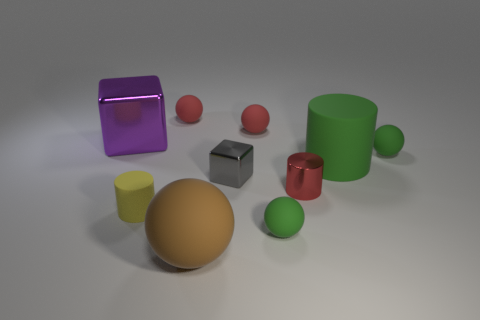What material is the red cylinder?
Make the answer very short. Metal. Do the large shiny object and the small yellow matte object have the same shape?
Give a very brief answer. No. Are there any other small yellow cylinders made of the same material as the small yellow cylinder?
Provide a succinct answer. No. There is a metal thing that is both right of the big purple metallic block and behind the red shiny object; what color is it?
Provide a succinct answer. Gray. There is a green ball that is in front of the yellow cylinder; what is its material?
Make the answer very short. Rubber. Is there a small cyan matte thing of the same shape as the gray thing?
Make the answer very short. No. How many other things are there of the same shape as the brown thing?
Keep it short and to the point. 4. There is a small gray object; is it the same shape as the green rubber object that is in front of the tiny yellow matte thing?
Your answer should be very brief. No. Are there any other things that are the same material as the tiny block?
Provide a succinct answer. Yes. There is a red object that is the same shape as the small yellow rubber object; what is its material?
Offer a very short reply. Metal. 